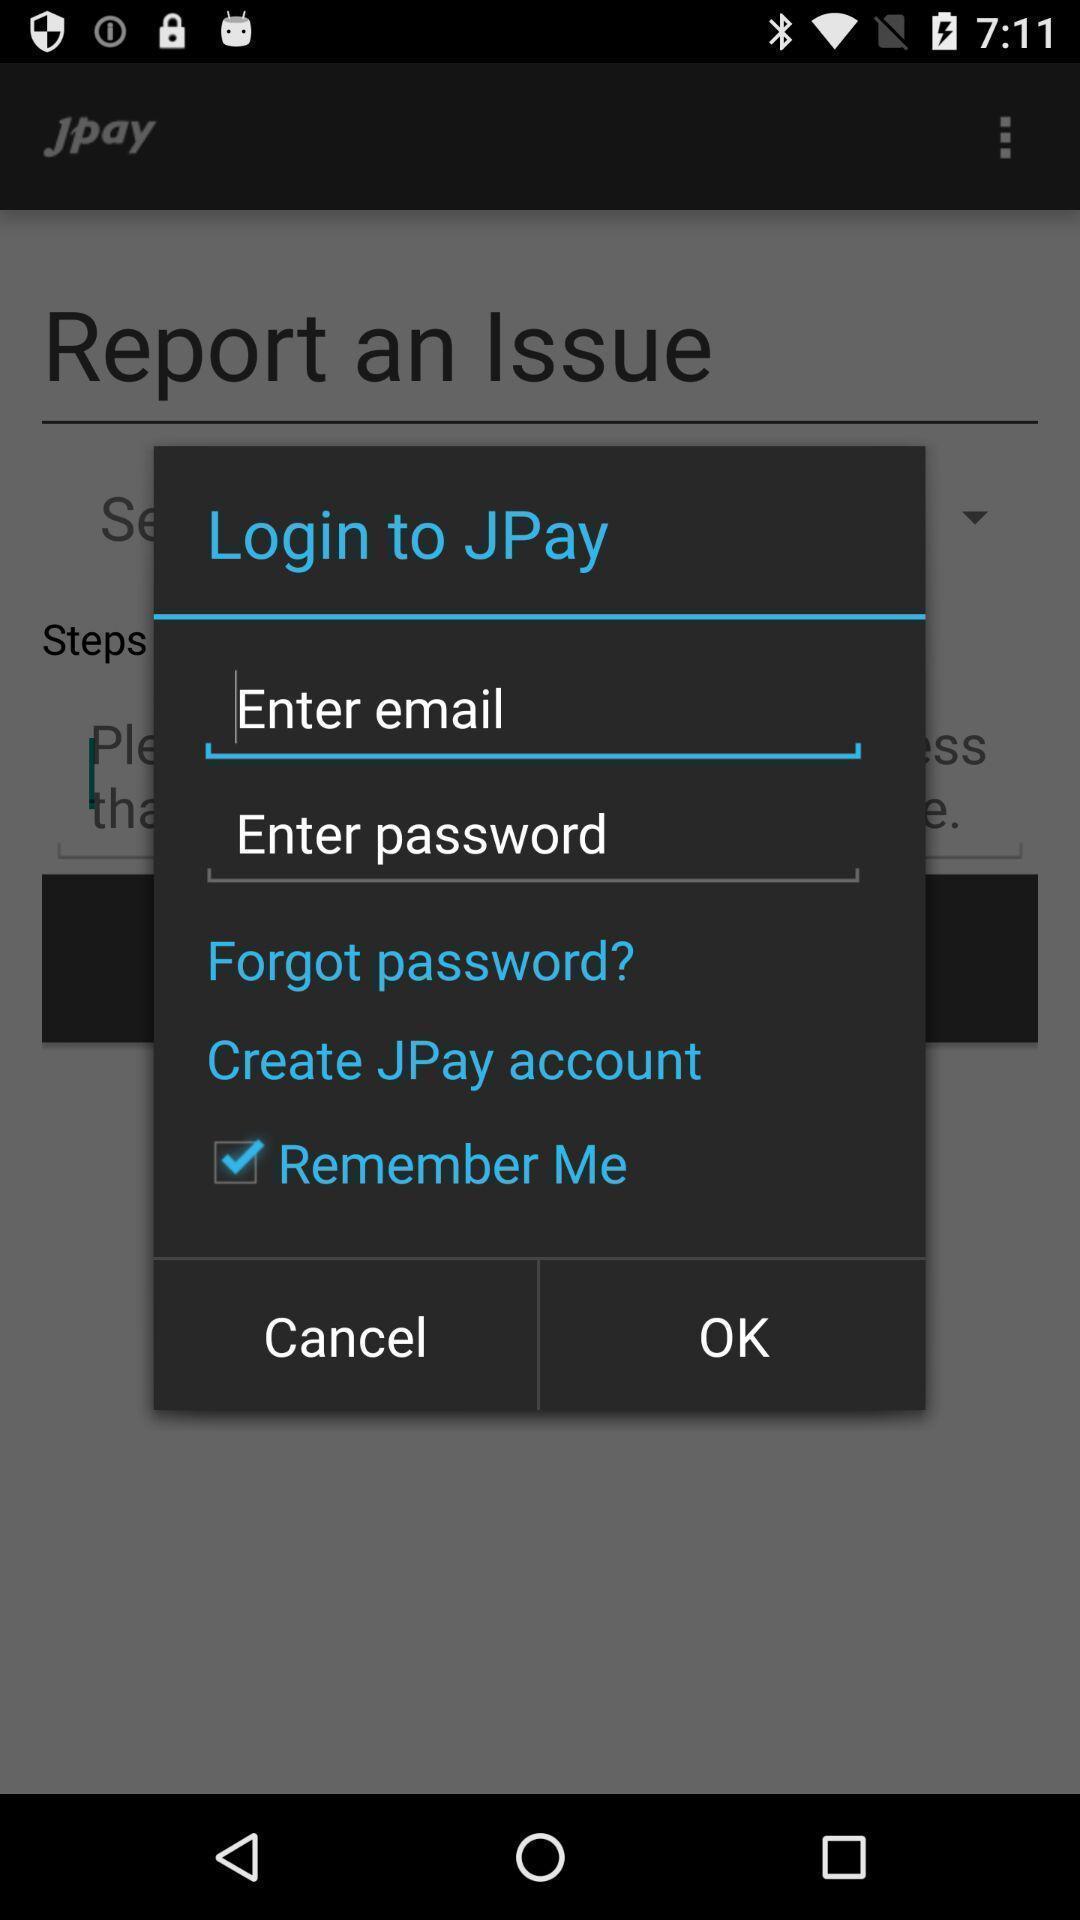What can you discern from this picture? Popup for login to enter email in a financial app. 